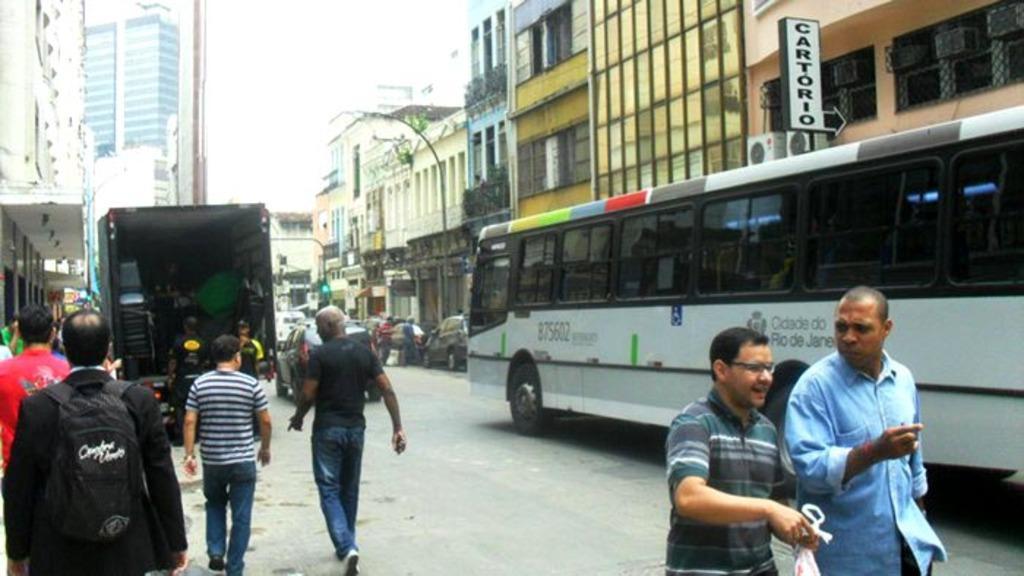How would you summarize this image in a sentence or two? At the bottom of the image we can see some people are walking on the road and a man is wearing a bag and another man is holding a cover. In the background of the image we can see the buildings, windows, boards, vehicles, traffic light, poles, light, air conditioner and some people are standing. At the bottom of the image we can see the road. At the top of the image we can see the sky. 